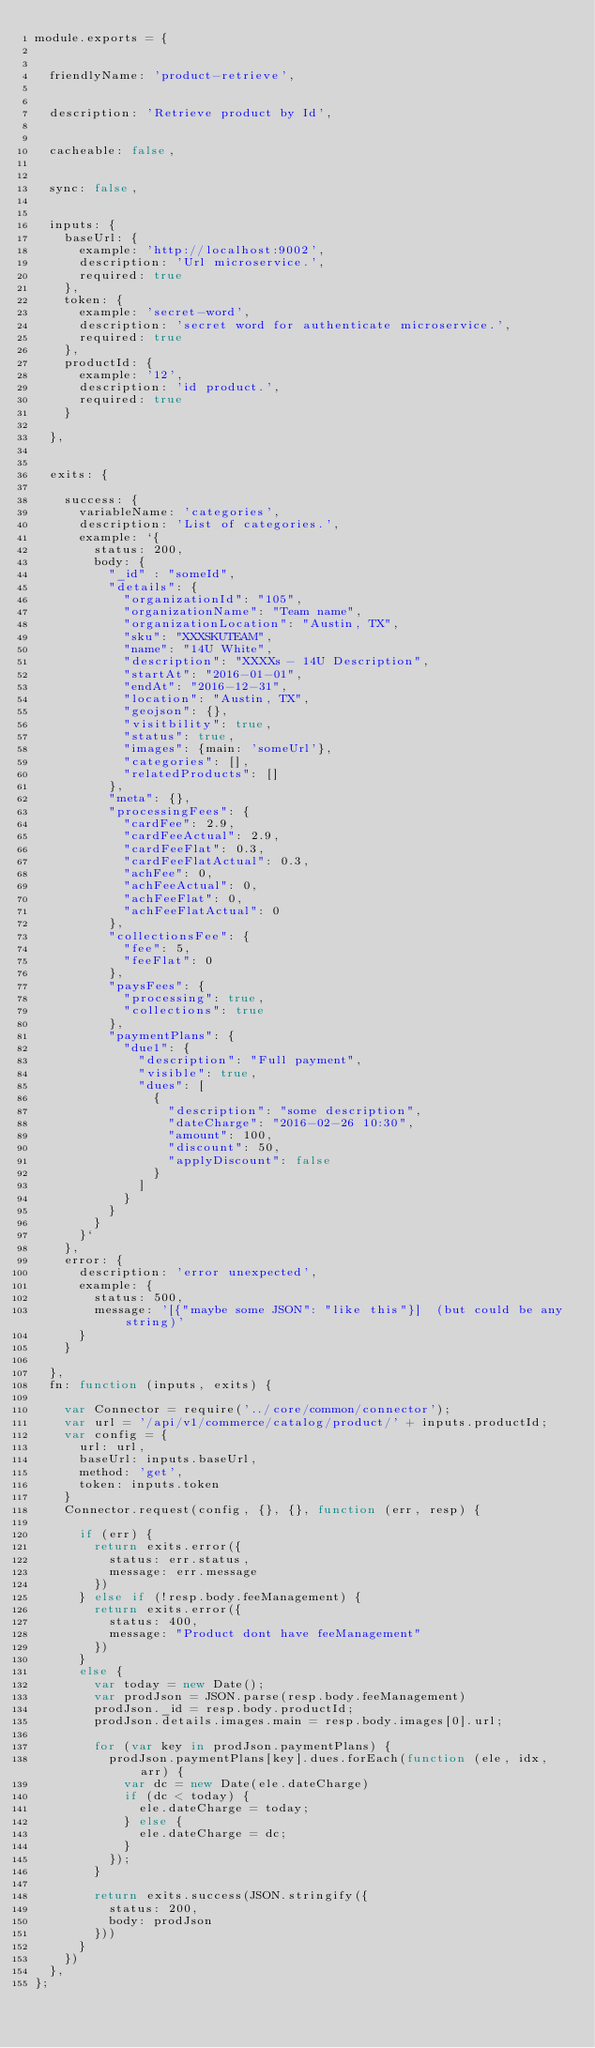<code> <loc_0><loc_0><loc_500><loc_500><_JavaScript_>module.exports = {


  friendlyName: 'product-retrieve',


  description: 'Retrieve product by Id',


  cacheable: false,


  sync: false,


  inputs: {
    baseUrl: {
      example: 'http://localhost:9002',
      description: 'Url microservice.',
      required: true
    },
    token: {
      example: 'secret-word',
      description: 'secret word for authenticate microservice.',
      required: true
    },
    productId: {
      example: '12',
      description: 'id product.',
      required: true
    }

  },


  exits: {

    success: {
      variableName: 'categories',
      description: 'List of categories.',
      example: `{
        status: 200,
        body: {
          "_id" : "someId",
          "details": {
            "organizationId": "105",
            "organizationName": "Team name",
            "organizationLocation": "Austin, TX",
            "sku": "XXXSKUTEAM",
            "name": "14U White",
            "description": "XXXXs - 14U Description",
            "startAt": "2016-01-01",
            "endAt": "2016-12-31",
            "location": "Austin, TX",
            "geojson": {},
            "visitbility": true,
            "status": true,
            "images": {main: 'someUrl'},
            "categories": [],
            "relatedProducts": []
          },
          "meta": {},
          "processingFees": {
            "cardFee": 2.9,
            "cardFeeActual": 2.9,
            "cardFeeFlat": 0.3,
            "cardFeeFlatActual": 0.3,
            "achFee": 0,
            "achFeeActual": 0,
            "achFeeFlat": 0,
            "achFeeFlatActual": 0
          },
          "collectionsFee": {
            "fee": 5,
            "feeFlat": 0
          },
          "paysFees": {
            "processing": true,
            "collections": true
          },
          "paymentPlans": {
            "due1": {
              "description": "Full payment",
              "visible": true,
              "dues": [
                {
                  "description": "some description",
                  "dateCharge": "2016-02-26 10:30",
                  "amount": 100,
                  "discount": 50,
                  "applyDiscount": false
                }
              ]
            }
          }
        }
      }`
    },
    error: {
      description: 'error unexpected',
      example: {
        status: 500,
        message: '[{"maybe some JSON": "like this"}]  (but could be any string)'
      }
    }

  },
  fn: function (inputs, exits) {

    var Connector = require('../core/common/connector');
    var url = '/api/v1/commerce/catalog/product/' + inputs.productId;
    var config = {
      url: url,
      baseUrl: inputs.baseUrl,
      method: 'get',
      token: inputs.token
    }
    Connector.request(config, {}, {}, function (err, resp) {

      if (err) {
        return exits.error({
          status: err.status,
          message: err.message
        })
      } else if (!resp.body.feeManagement) {
        return exits.error({
          status: 400,
          message: "Product dont have feeManagement"
        })
      }
      else {
        var today = new Date();
        var prodJson = JSON.parse(resp.body.feeManagement)
        prodJson._id = resp.body.productId;
        prodJson.details.images.main = resp.body.images[0].url;

        for (var key in prodJson.paymentPlans) {
          prodJson.paymentPlans[key].dues.forEach(function (ele, idx, arr) {
            var dc = new Date(ele.dateCharge)
            if (dc < today) {
              ele.dateCharge = today;
            } else {
              ele.dateCharge = dc;
            }
          });
        }

        return exits.success(JSON.stringify({
          status: 200,
          body: prodJson
        }))
      }
    })
  },
};
</code> 